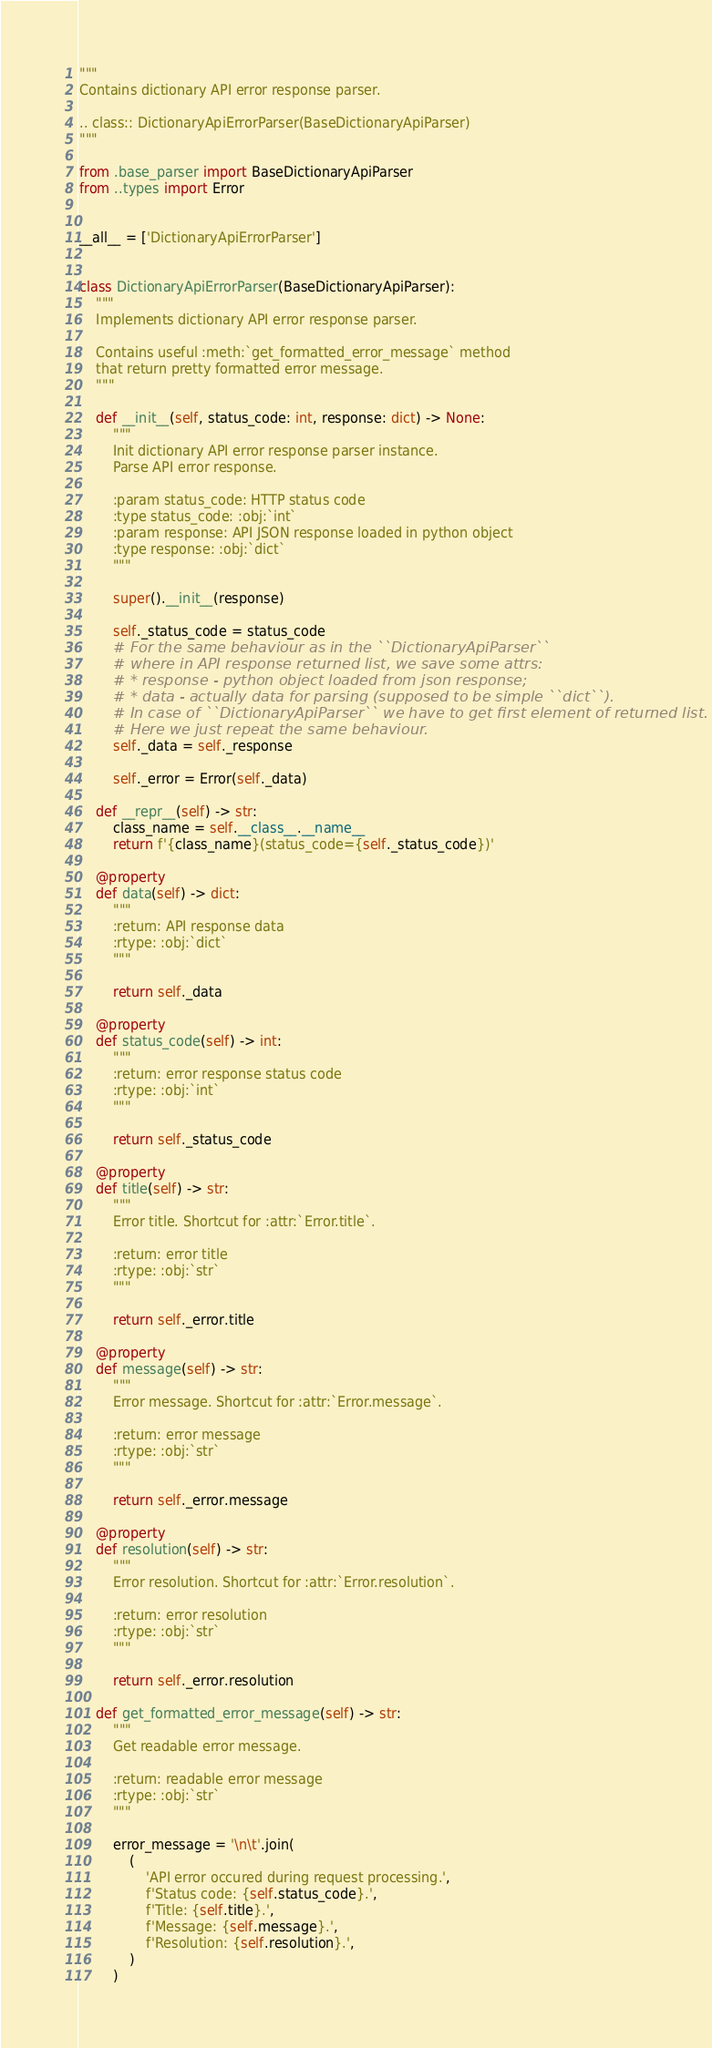<code> <loc_0><loc_0><loc_500><loc_500><_Python_>"""
Contains dictionary API error response parser.

.. class:: DictionaryApiErrorParser(BaseDictionaryApiParser)
"""

from .base_parser import BaseDictionaryApiParser
from ..types import Error


__all__ = ['DictionaryApiErrorParser']


class DictionaryApiErrorParser(BaseDictionaryApiParser):
    """
    Implements dictionary API error response parser.

    Contains useful :meth:`get_formatted_error_message` method
    that return pretty formatted error message.
    """

    def __init__(self, status_code: int, response: dict) -> None:
        """
        Init dictionary API error response parser instance.
        Parse API error response.

        :param status_code: HTTP status code
        :type status_code: :obj:`int`
        :param response: API JSON response loaded in python object
        :type response: :obj:`dict`
        """

        super().__init__(response)

        self._status_code = status_code
        # For the same behaviour as in the ``DictionaryApiParser``
        # where in API response returned list, we save some attrs:
        # * response - python object loaded from json response;
        # * data - actually data for parsing (supposed to be simple ``dict``).
        # In case of ``DictionaryApiParser`` we have to get first element of returned list.
        # Here we just repeat the same behaviour.
        self._data = self._response

        self._error = Error(self._data)

    def __repr__(self) -> str:
        class_name = self.__class__.__name__
        return f'{class_name}(status_code={self._status_code})'

    @property
    def data(self) -> dict:
        """
        :return: API response data
        :rtype: :obj:`dict`
        """

        return self._data

    @property
    def status_code(self) -> int:
        """
        :return: error response status code
        :rtype: :obj:`int`
        """

        return self._status_code

    @property
    def title(self) -> str:
        """
        Error title. Shortcut for :attr:`Error.title`.

        :return: error title
        :rtype: :obj:`str`
        """

        return self._error.title

    @property
    def message(self) -> str:
        """
        Error message. Shortcut for :attr:`Error.message`.

        :return: error message
        :rtype: :obj:`str`
        """

        return self._error.message

    @property
    def resolution(self) -> str:
        """
        Error resolution. Shortcut for :attr:`Error.resolution`.

        :return: error resolution
        :rtype: :obj:`str`
        """

        return self._error.resolution

    def get_formatted_error_message(self) -> str:
        """
        Get readable error message.

        :return: readable error message
        :rtype: :obj:`str`
        """

        error_message = '\n\t'.join(
            (
                'API error occured during request processing.',
                f'Status code: {self.status_code}.',
                f'Title: {self.title}.',
                f'Message: {self.message}.',
                f'Resolution: {self.resolution}.',
            )
        )
</code> 